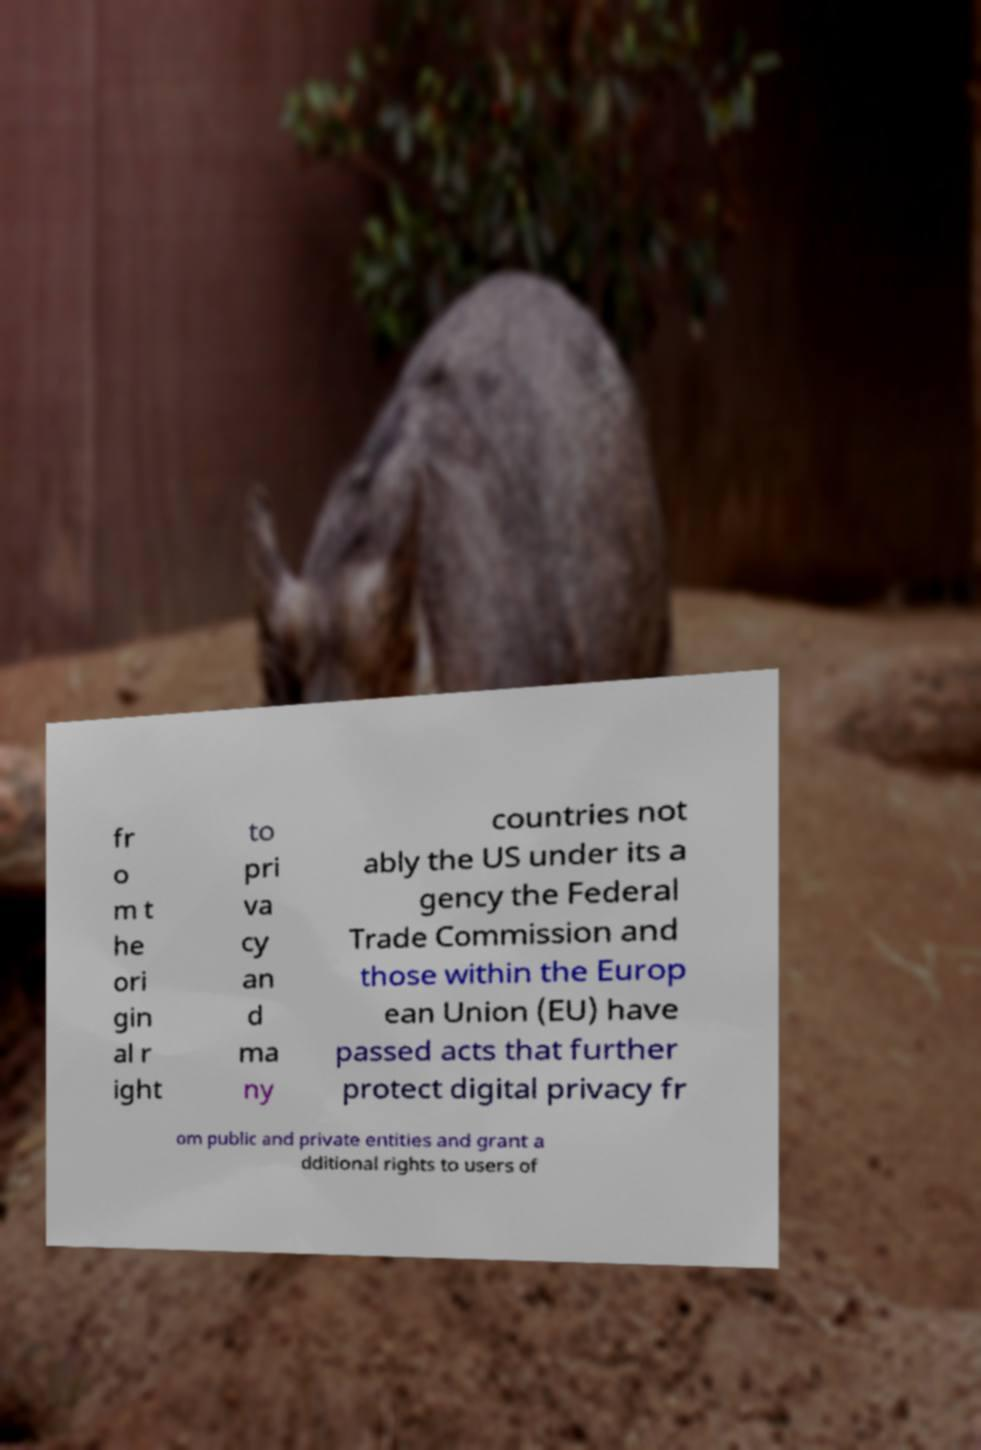For documentation purposes, I need the text within this image transcribed. Could you provide that? fr o m t he ori gin al r ight to pri va cy an d ma ny countries not ably the US under its a gency the Federal Trade Commission and those within the Europ ean Union (EU) have passed acts that further protect digital privacy fr om public and private entities and grant a dditional rights to users of 